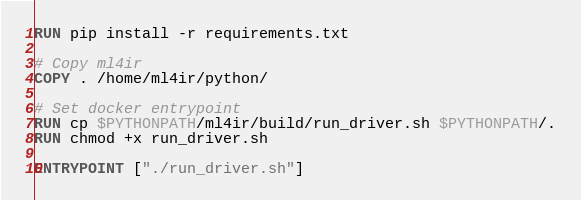<code> <loc_0><loc_0><loc_500><loc_500><_Dockerfile_>RUN pip install -r requirements.txt

# Copy ml4ir
COPY . /home/ml4ir/python/

# Set docker entrypoint
RUN cp $PYTHONPATH/ml4ir/build/run_driver.sh $PYTHONPATH/.
RUN chmod +x run_driver.sh

ENTRYPOINT ["./run_driver.sh"]
</code> 